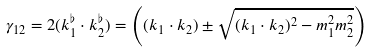<formula> <loc_0><loc_0><loc_500><loc_500>\gamma _ { 1 2 } & = 2 ( k ^ { \flat } _ { 1 } \cdot k ^ { \flat } _ { 2 } ) = \left ( ( k _ { 1 } \cdot k _ { 2 } ) \pm \sqrt { ( k _ { 1 } \cdot k _ { 2 } ) ^ { 2 } - m _ { 1 } ^ { 2 } m _ { 2 } ^ { 2 } } \right )</formula> 